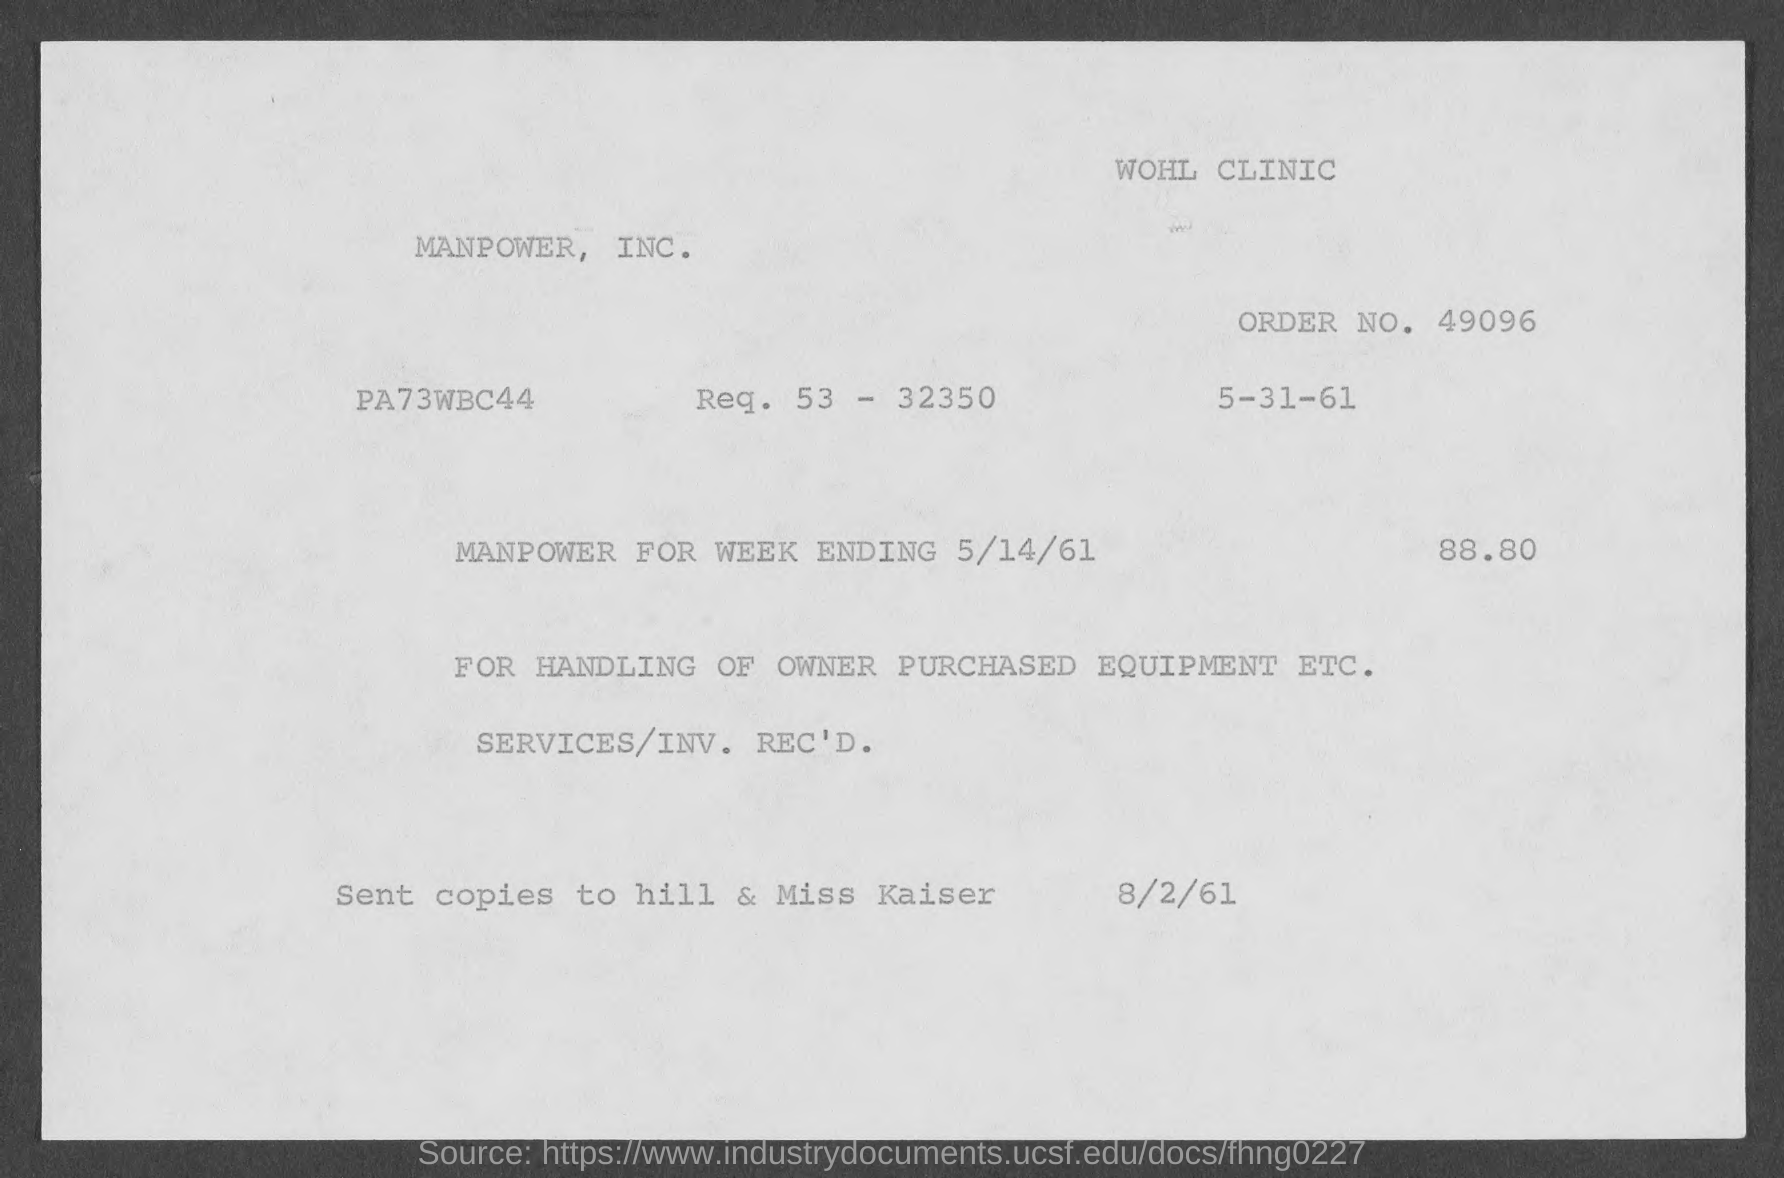What is the order no. mentioned in the given page ?
Offer a very short reply. 49096. What is the amount mentioned in the given form ?
Ensure brevity in your answer.  88.80. What is the date mentioned in the given form ?
Offer a terse response. 5-31-61. What is the date of manpower for week ending ?
Offer a terse response. 5/14/61. 